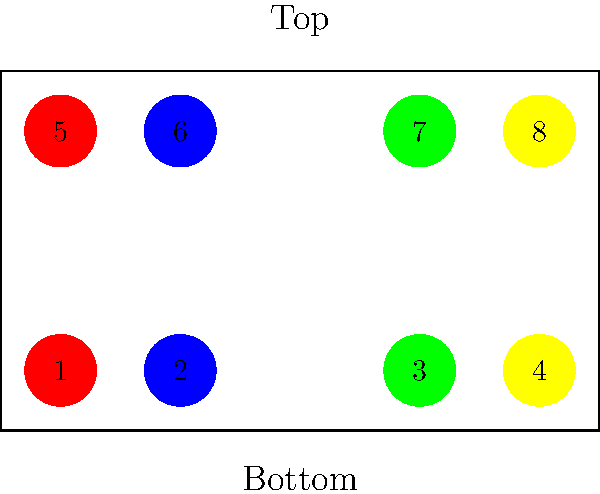In a Scottish Country Dance set with 4 couples, the dancers are arranged as shown in the diagram. If the dance calls for a "half figure of eight" across the set, starting with the 1st man (red) crossing down, how will the positions of the 1st couple (red) and 2nd couple (blue) change after completing the figure? To understand the progression after a half figure of eight:

1. Initial positions:
   - 1st couple (red): positions 1 and 5
   - 2nd couple (blue): positions 2 and 6

2. Half figure of eight progression:
   a. 1st man (position 1) crosses down between 2nd couple
   b. 1st woman (position 5) crosses down between 2nd couple, following her partner
   c. 2nd man (position 2) crosses up to the top on the women's side
   d. 2nd woman (position 6) crosses up to the top on the men's side

3. Final positions after the half figure of eight:
   - 1st man: moves to position 6
   - 1st woman: moves to position 2
   - 2nd man: moves to position 5
   - 2nd woman: moves to position 1

4. Result:
   - 1st couple has progressed one place down the set
   - 2nd couple has progressed one place up the set
   - They have also changed sides of the set
Answer: 1st couple down one place on opposite sides, 2nd couple up one place on opposite sides 